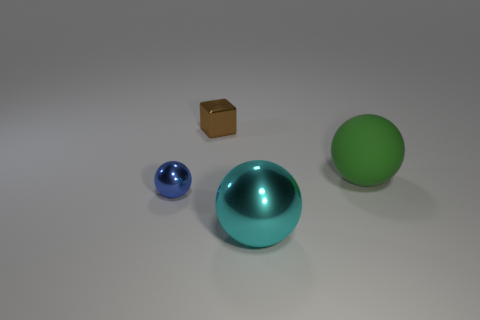There is a cyan metal thing; does it have the same size as the sphere that is on the right side of the big cyan thing?
Offer a terse response. Yes. What number of other things are there of the same size as the green thing?
Your answer should be compact. 1. How many other things are the same color as the block?
Make the answer very short. 0. Is there any other thing that has the same size as the metal block?
Offer a very short reply. Yes. How many other things are there of the same shape as the green matte object?
Your answer should be very brief. 2. Is the rubber sphere the same size as the cyan metallic sphere?
Provide a short and direct response. Yes. Is there a big matte cube?
Your answer should be very brief. No. Is there any other thing that is the same material as the big cyan thing?
Your response must be concise. Yes. Are there any cyan things that have the same material as the blue thing?
Give a very brief answer. Yes. There is a brown object that is the same size as the blue object; what material is it?
Your answer should be very brief. Metal. 